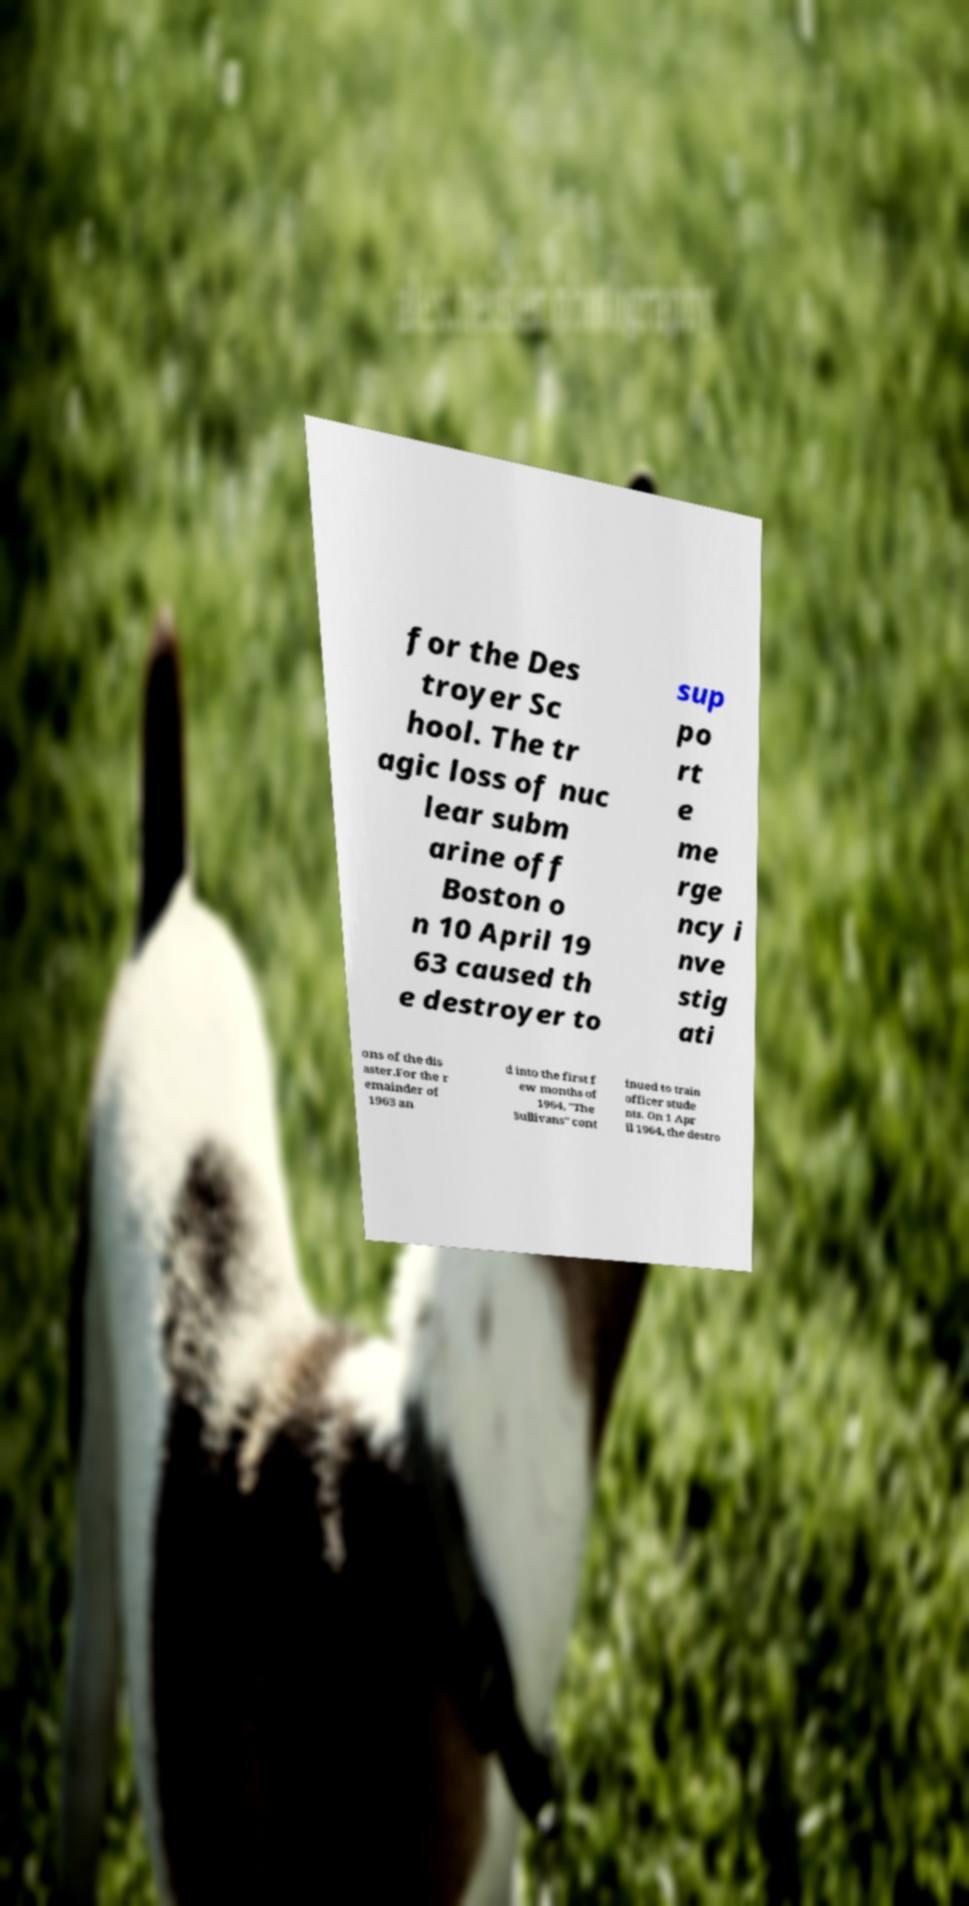I need the written content from this picture converted into text. Can you do that? for the Des troyer Sc hool. The tr agic loss of nuc lear subm arine off Boston o n 10 April 19 63 caused th e destroyer to sup po rt e me rge ncy i nve stig ati ons of the dis aster.For the r emainder of 1963 an d into the first f ew months of 1964, "The Sullivans" cont inued to train officer stude nts. On 1 Apr il 1964, the destro 